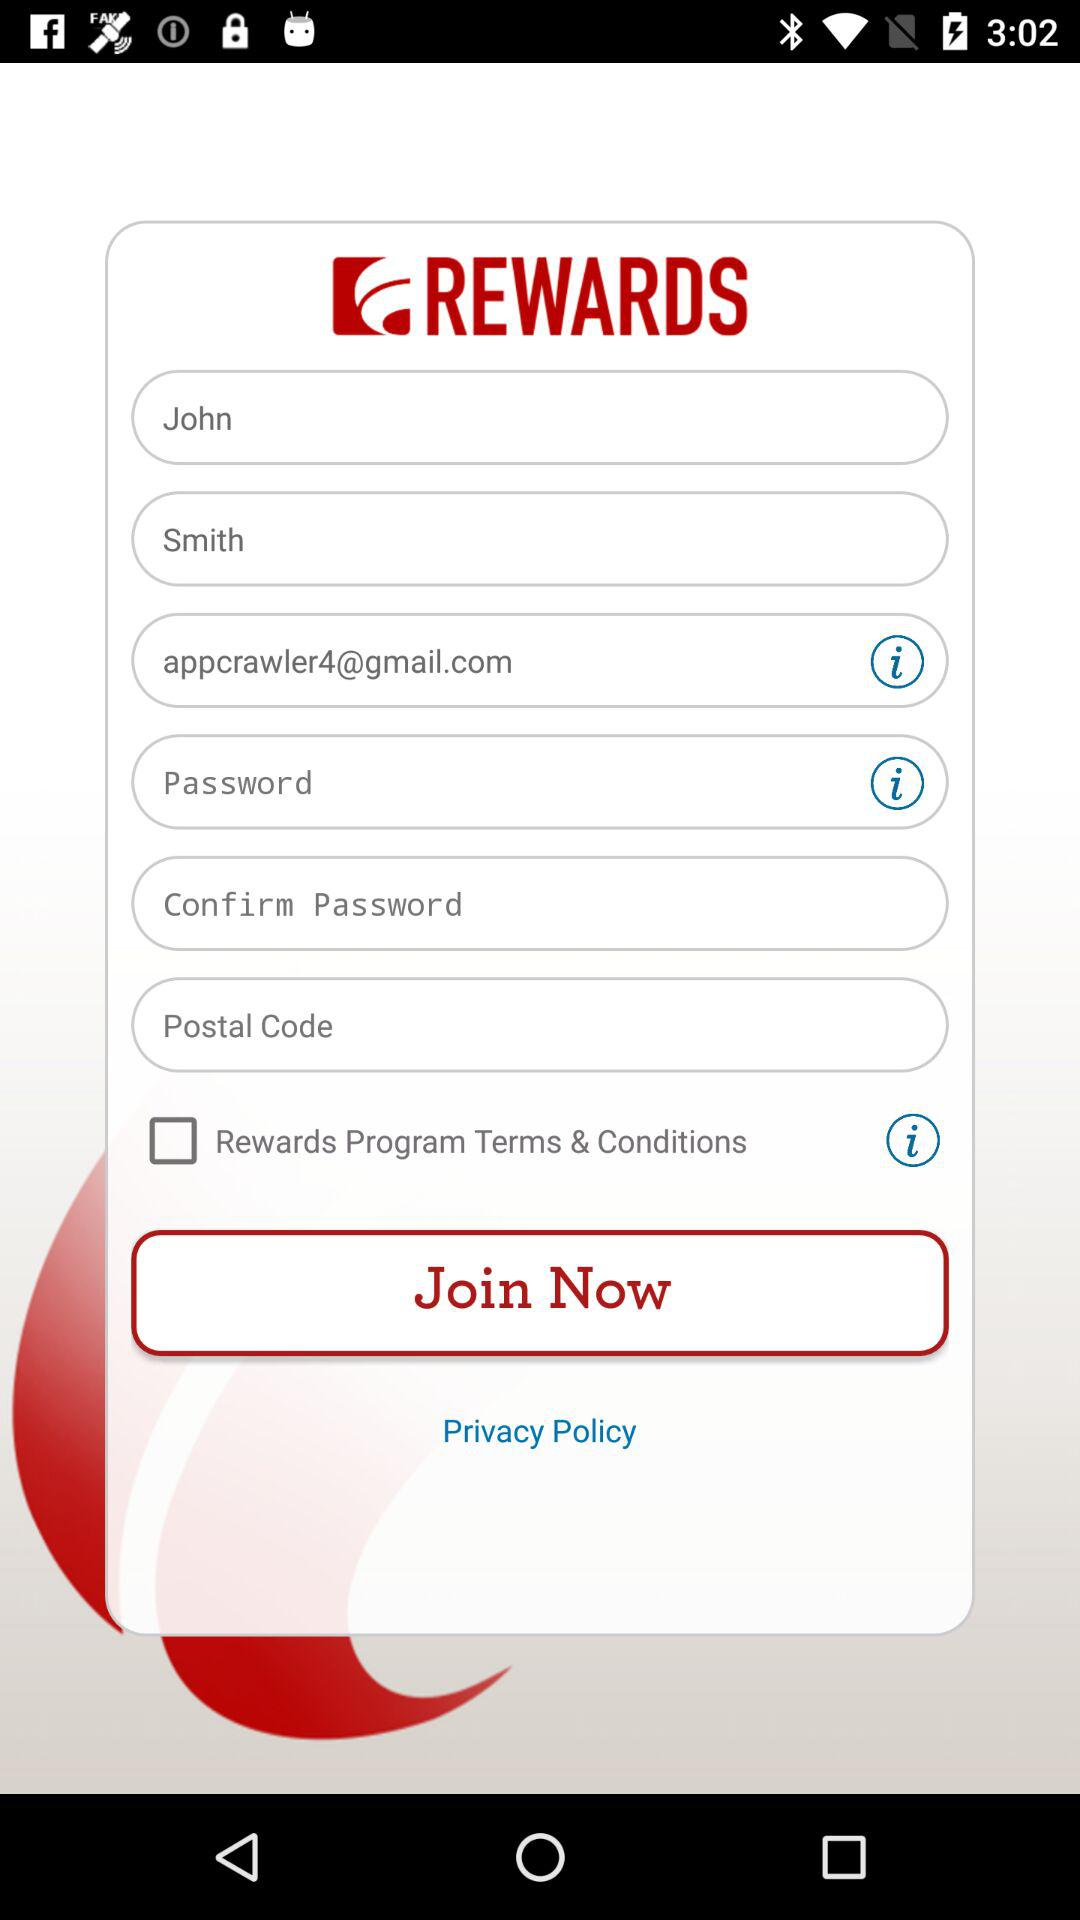What is the email address? The email address is appcrawler4@gmail.com. 